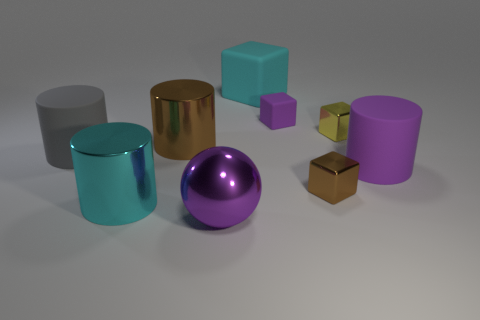Add 1 gray objects. How many objects exist? 10 Subtract all blocks. How many objects are left? 5 Subtract 0 cyan spheres. How many objects are left? 9 Subtract all big yellow things. Subtract all tiny purple rubber objects. How many objects are left? 8 Add 3 big matte blocks. How many big matte blocks are left? 4 Add 7 large brown metal objects. How many large brown metal objects exist? 8 